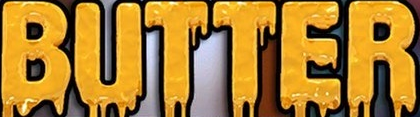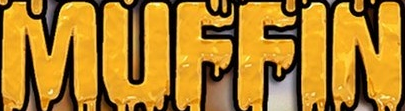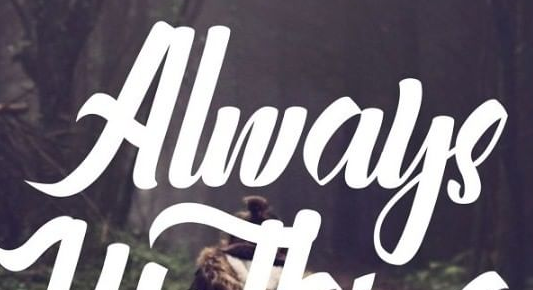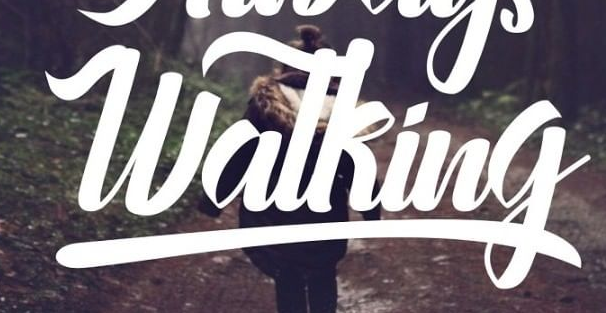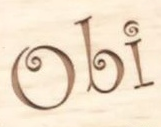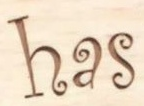Read the text from these images in sequence, separated by a semicolon. BUTTER; MUFFIN; Always; Watking; Obi; has 